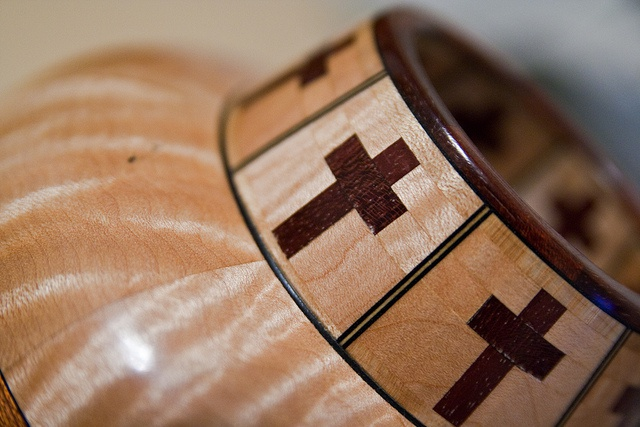Describe the objects in this image and their specific colors. I can see a vase in tan, gray, and black tones in this image. 